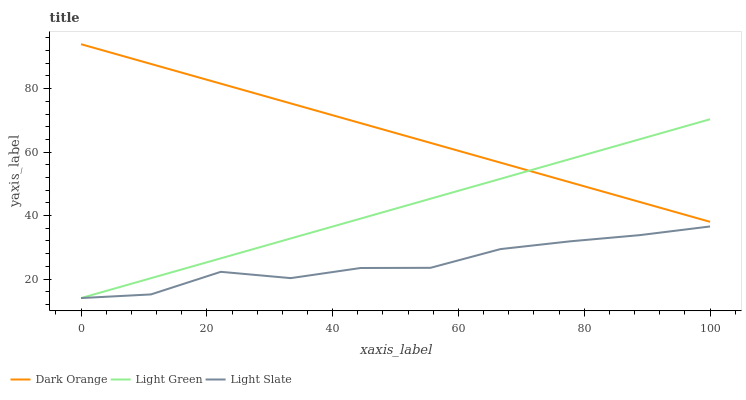Does Light Slate have the minimum area under the curve?
Answer yes or no. Yes. Does Dark Orange have the maximum area under the curve?
Answer yes or no. Yes. Does Light Green have the minimum area under the curve?
Answer yes or no. No. Does Light Green have the maximum area under the curve?
Answer yes or no. No. Is Dark Orange the smoothest?
Answer yes or no. Yes. Is Light Slate the roughest?
Answer yes or no. Yes. Is Light Green the smoothest?
Answer yes or no. No. Is Light Green the roughest?
Answer yes or no. No. Does Light Slate have the lowest value?
Answer yes or no. Yes. Does Dark Orange have the lowest value?
Answer yes or no. No. Does Dark Orange have the highest value?
Answer yes or no. Yes. Does Light Green have the highest value?
Answer yes or no. No. Is Light Slate less than Dark Orange?
Answer yes or no. Yes. Is Dark Orange greater than Light Slate?
Answer yes or no. Yes. Does Dark Orange intersect Light Green?
Answer yes or no. Yes. Is Dark Orange less than Light Green?
Answer yes or no. No. Is Dark Orange greater than Light Green?
Answer yes or no. No. Does Light Slate intersect Dark Orange?
Answer yes or no. No. 